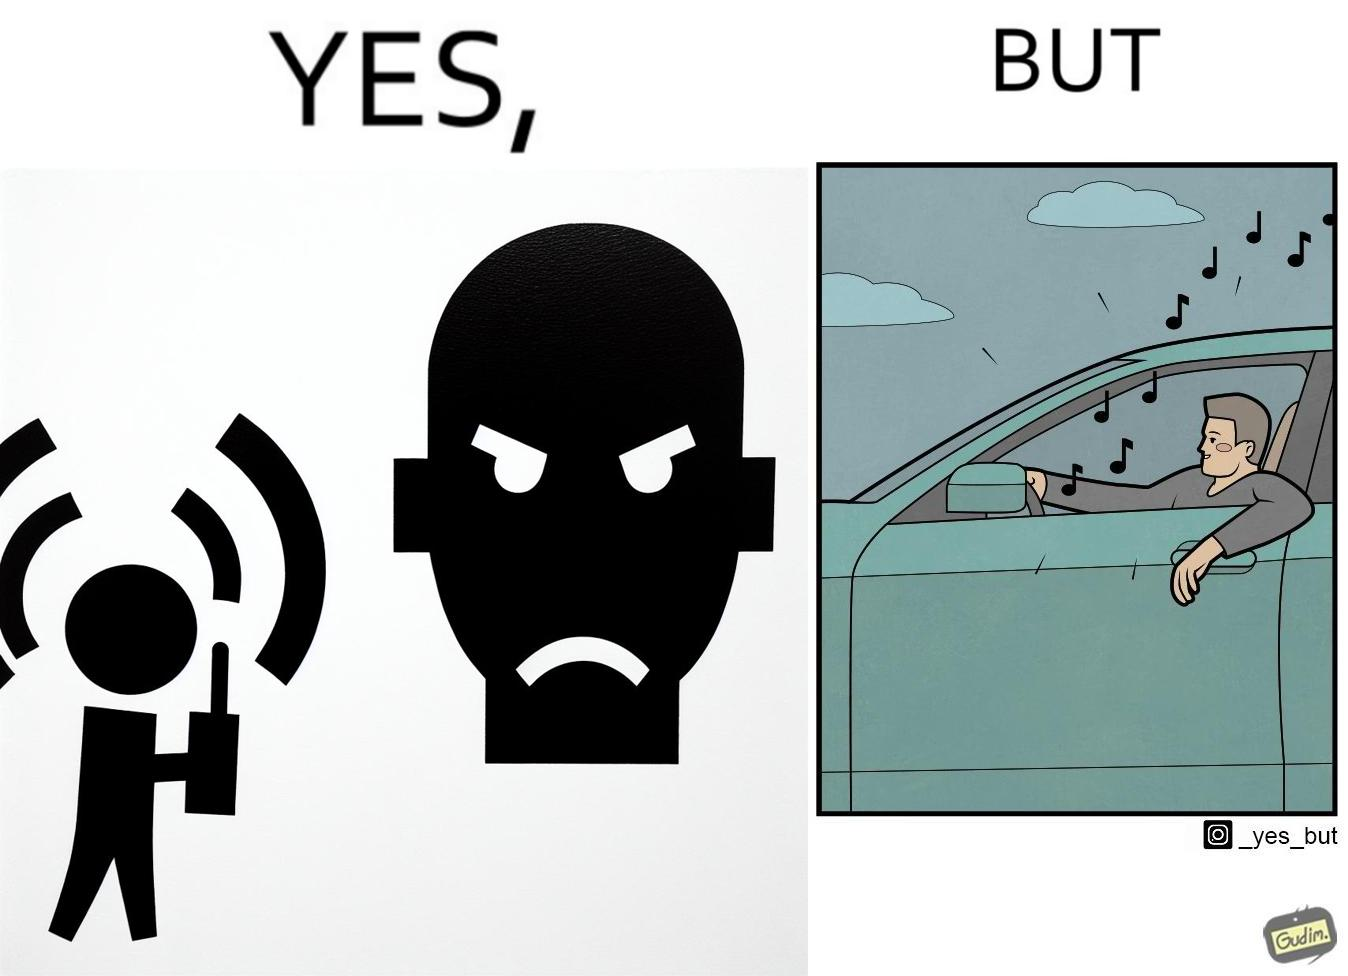Describe the contrast between the left and right parts of this image. In the left part of the image: The image shows a boy playing music on his phone loudly. The image also shows another man annoyed by the loud music. In the right part of the image: The image shows a man driving a car with the windows of the car rolled down. He has one of his hands on the steering wheel and the other hand hanging out of the window of the driver side of the car. The man is playing loud music in his car with the sound coming out of the car. 